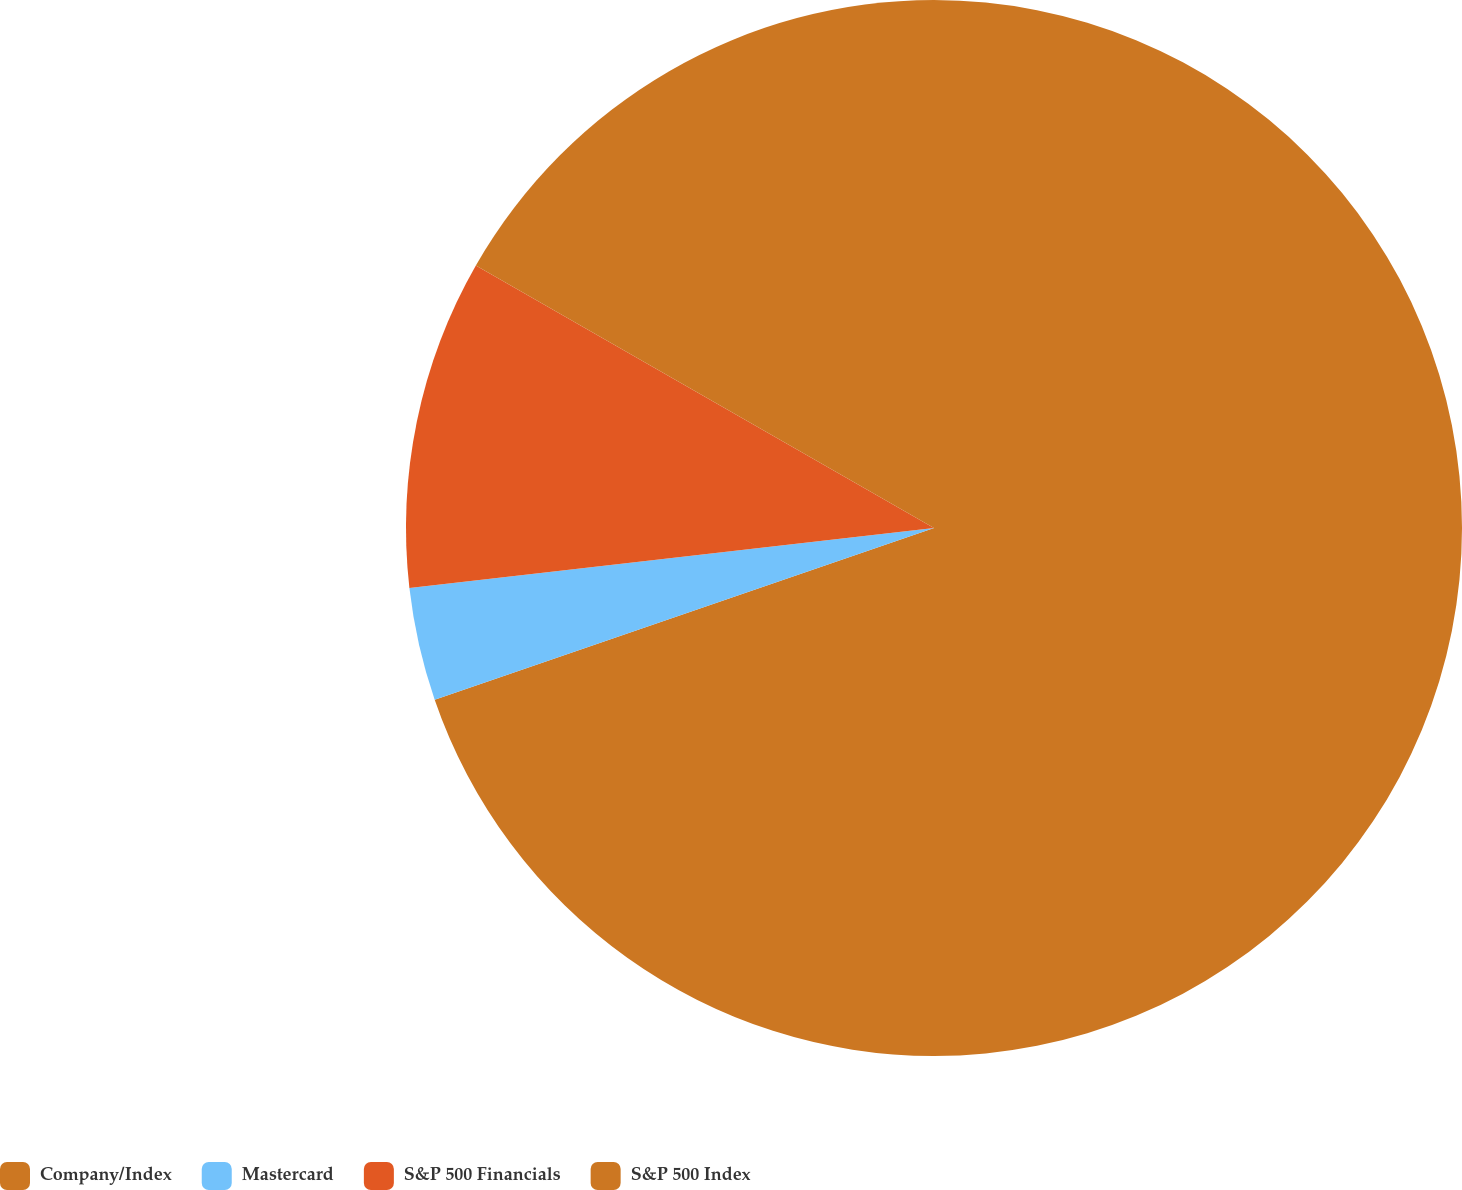Convert chart. <chart><loc_0><loc_0><loc_500><loc_500><pie_chart><fcel>Company/Index<fcel>Mastercard<fcel>S&P 500 Financials<fcel>S&P 500 Index<nl><fcel>69.73%<fcel>3.46%<fcel>10.09%<fcel>16.72%<nl></chart> 